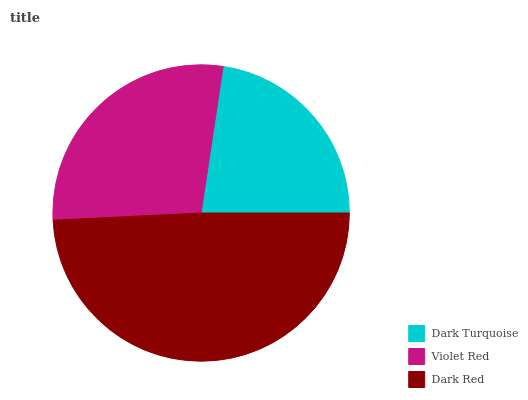Is Dark Turquoise the minimum?
Answer yes or no. Yes. Is Dark Red the maximum?
Answer yes or no. Yes. Is Violet Red the minimum?
Answer yes or no. No. Is Violet Red the maximum?
Answer yes or no. No. Is Violet Red greater than Dark Turquoise?
Answer yes or no. Yes. Is Dark Turquoise less than Violet Red?
Answer yes or no. Yes. Is Dark Turquoise greater than Violet Red?
Answer yes or no. No. Is Violet Red less than Dark Turquoise?
Answer yes or no. No. Is Violet Red the high median?
Answer yes or no. Yes. Is Violet Red the low median?
Answer yes or no. Yes. Is Dark Turquoise the high median?
Answer yes or no. No. Is Dark Turquoise the low median?
Answer yes or no. No. 